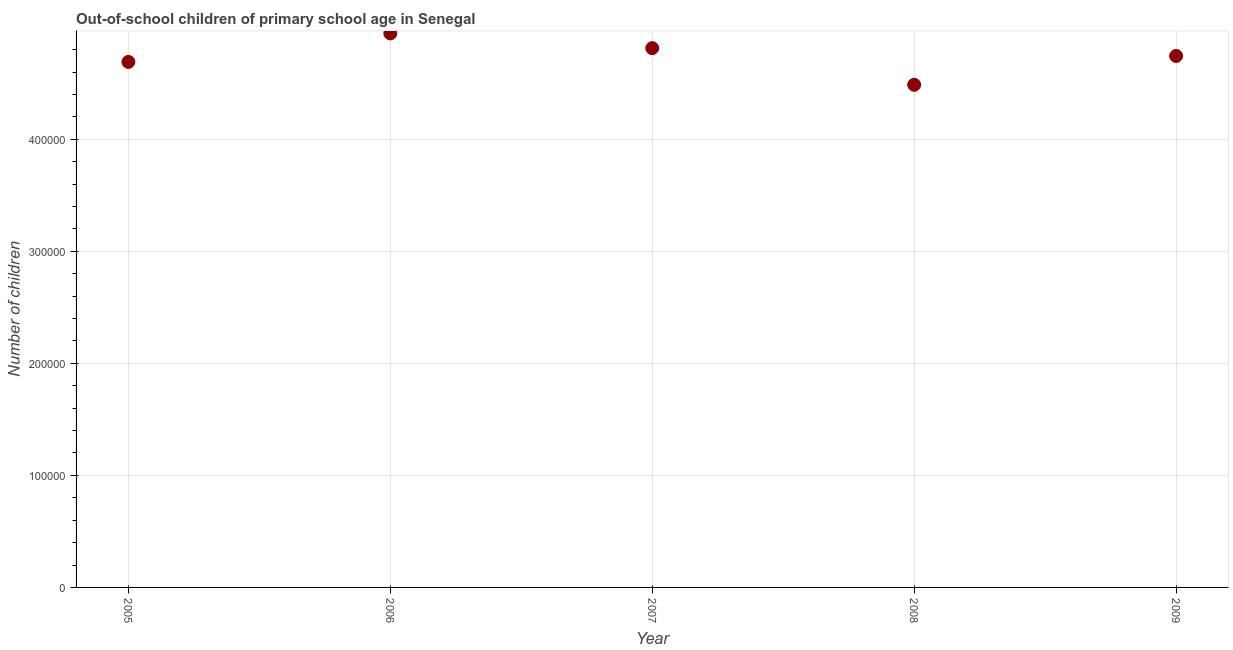What is the number of out-of-school children in 2009?
Ensure brevity in your answer.  4.74e+05. Across all years, what is the maximum number of out-of-school children?
Keep it short and to the point. 4.95e+05. Across all years, what is the minimum number of out-of-school children?
Provide a succinct answer. 4.49e+05. In which year was the number of out-of-school children maximum?
Give a very brief answer. 2006. In which year was the number of out-of-school children minimum?
Offer a terse response. 2008. What is the sum of the number of out-of-school children?
Your answer should be compact. 2.37e+06. What is the difference between the number of out-of-school children in 2006 and 2009?
Keep it short and to the point. 2.02e+04. What is the average number of out-of-school children per year?
Your response must be concise. 4.74e+05. What is the median number of out-of-school children?
Provide a succinct answer. 4.74e+05. What is the ratio of the number of out-of-school children in 2005 to that in 2009?
Your answer should be compact. 0.99. Is the number of out-of-school children in 2006 less than that in 2009?
Ensure brevity in your answer.  No. What is the difference between the highest and the second highest number of out-of-school children?
Give a very brief answer. 1.32e+04. Is the sum of the number of out-of-school children in 2005 and 2008 greater than the maximum number of out-of-school children across all years?
Keep it short and to the point. Yes. What is the difference between the highest and the lowest number of out-of-school children?
Keep it short and to the point. 4.59e+04. In how many years, is the number of out-of-school children greater than the average number of out-of-school children taken over all years?
Keep it short and to the point. 3. Does the number of out-of-school children monotonically increase over the years?
Provide a succinct answer. No. How many dotlines are there?
Give a very brief answer. 1. Does the graph contain any zero values?
Provide a short and direct response. No. Does the graph contain grids?
Your answer should be compact. Yes. What is the title of the graph?
Make the answer very short. Out-of-school children of primary school age in Senegal. What is the label or title of the Y-axis?
Keep it short and to the point. Number of children. What is the Number of children in 2005?
Your answer should be very brief. 4.69e+05. What is the Number of children in 2006?
Give a very brief answer. 4.95e+05. What is the Number of children in 2007?
Offer a terse response. 4.81e+05. What is the Number of children in 2008?
Make the answer very short. 4.49e+05. What is the Number of children in 2009?
Offer a very short reply. 4.74e+05. What is the difference between the Number of children in 2005 and 2006?
Offer a terse response. -2.55e+04. What is the difference between the Number of children in 2005 and 2007?
Provide a succinct answer. -1.23e+04. What is the difference between the Number of children in 2005 and 2008?
Provide a short and direct response. 2.04e+04. What is the difference between the Number of children in 2005 and 2009?
Ensure brevity in your answer.  -5300. What is the difference between the Number of children in 2006 and 2007?
Offer a terse response. 1.32e+04. What is the difference between the Number of children in 2006 and 2008?
Provide a succinct answer. 4.59e+04. What is the difference between the Number of children in 2006 and 2009?
Your answer should be compact. 2.02e+04. What is the difference between the Number of children in 2007 and 2008?
Your response must be concise. 3.27e+04. What is the difference between the Number of children in 2007 and 2009?
Your answer should be very brief. 6987. What is the difference between the Number of children in 2008 and 2009?
Your response must be concise. -2.57e+04. What is the ratio of the Number of children in 2005 to that in 2006?
Your response must be concise. 0.95. What is the ratio of the Number of children in 2005 to that in 2008?
Your answer should be very brief. 1.05. What is the ratio of the Number of children in 2006 to that in 2007?
Keep it short and to the point. 1.03. What is the ratio of the Number of children in 2006 to that in 2008?
Keep it short and to the point. 1.1. What is the ratio of the Number of children in 2006 to that in 2009?
Provide a succinct answer. 1.04. What is the ratio of the Number of children in 2007 to that in 2008?
Your response must be concise. 1.07. What is the ratio of the Number of children in 2008 to that in 2009?
Provide a short and direct response. 0.95. 